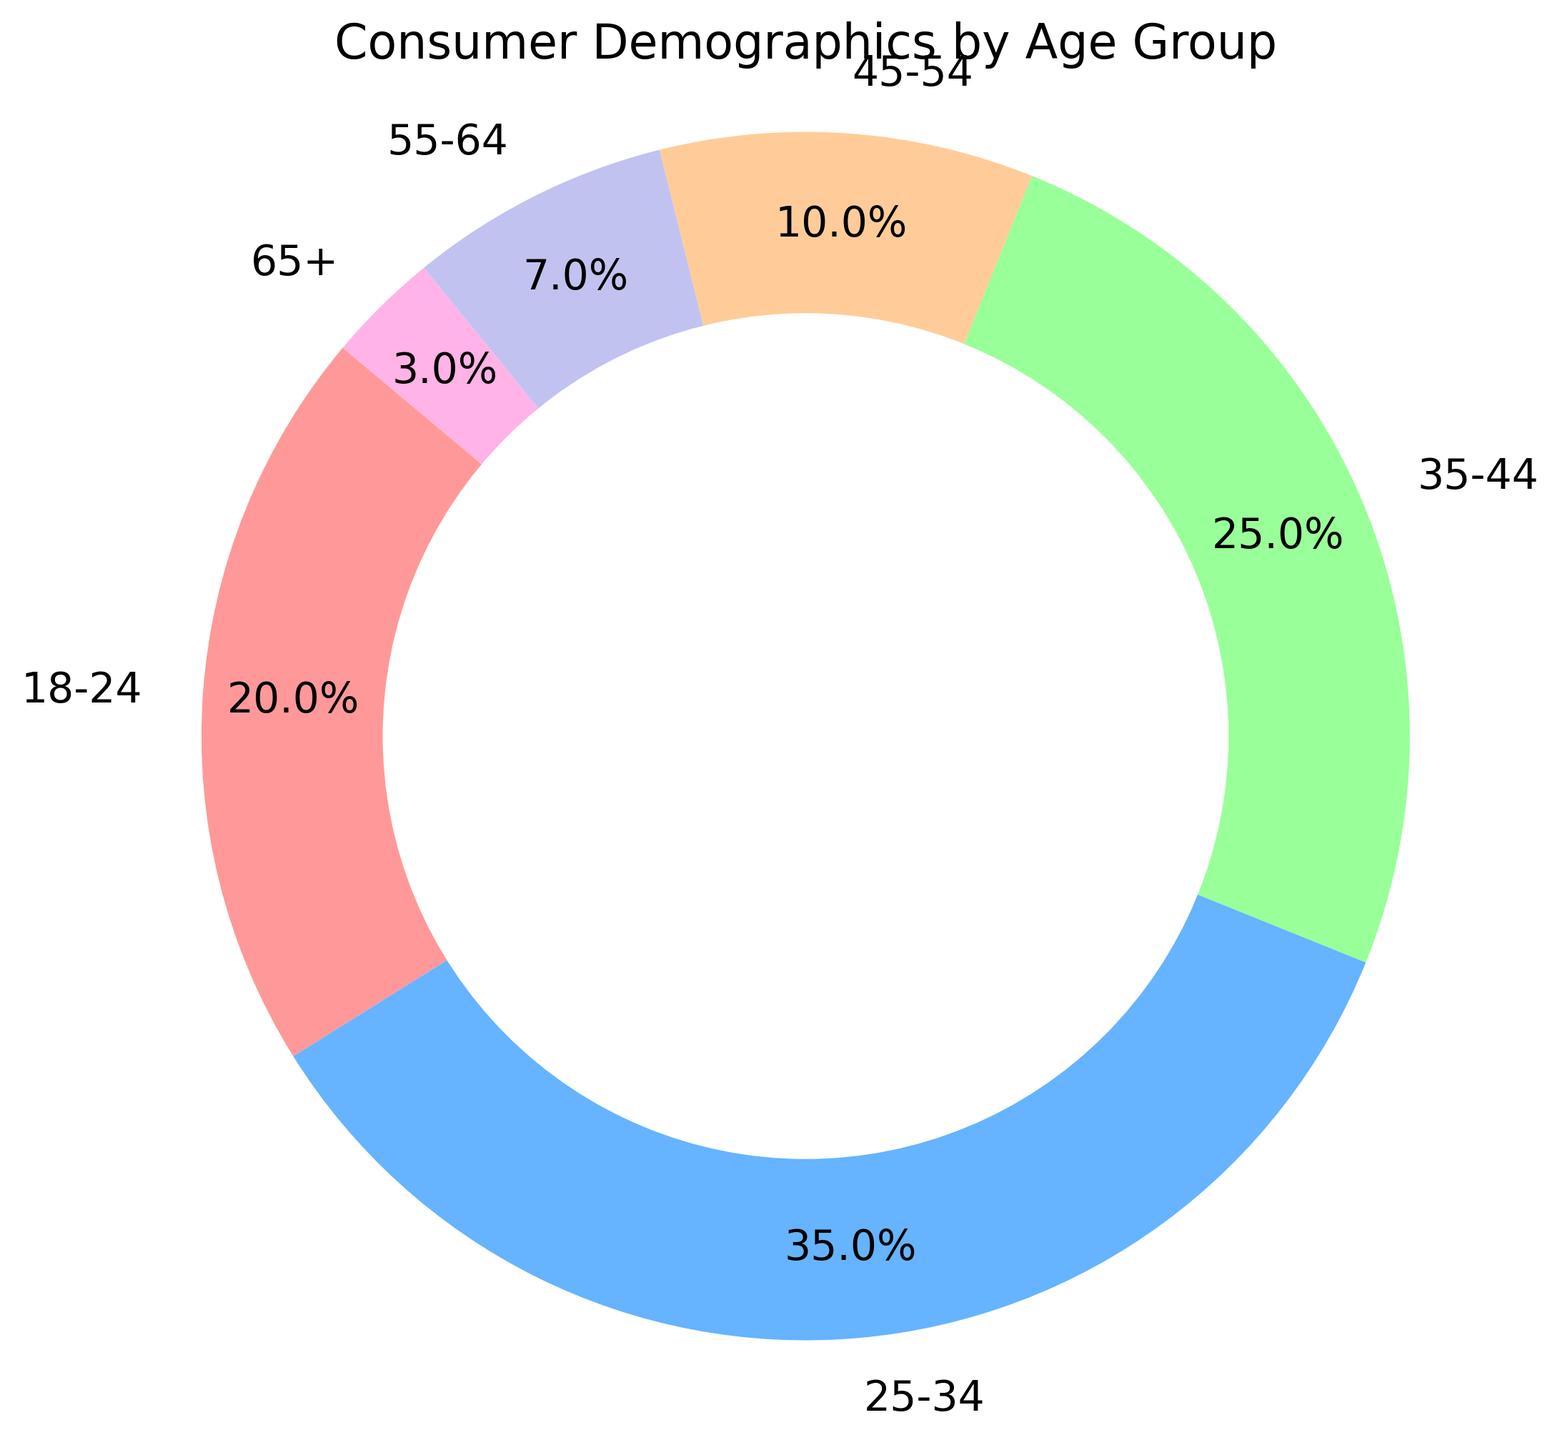What age group has the highest percentage of consumers for the specific product? Observing the pie chart, the largest segment represents the 25-34 age group. This segment occupies 35% of the chart, which is larger than any other group.
Answer: 25-34 Which two age groups together make up 70% of consumers? Adding the percentages of the two largest segments: 25-34 makes up 35% and 35-44 makes up 25%. Together, 35% + 25% equals 60%. To reach 70%, we need another 10%, which comes from the 18-24 group. Thus, 25-34 (35%) + 35-44 (25%) + 18-24 (20%) equals 70%.
Answer: 25-34 and 35-44 What is the difference in consumer percentage between the 18-24 age group and the 65+ age group? The 18-24 age group has 20%, while the 65+ age group has 3%. 20% - 3% equals a 17% difference.
Answer: 17% How does the consumer percentage of the 55-64 age group compare to the 45-54 age group? The chart shows that the 45-54 age group comprises 10%, whereas the 55-64 age group makes up 7%. Therefore, the 55-64 age group is 3% less than the 45-54 age group.
Answer: 3% less What is the total percentage of consumers aged 35 and above? Summing up the percentages of age groups 35-44 (25%), 45-54 (10%), 55-64 (7%), and 65+ (3%) gives 25% + 10% + 7% + 3% = 45%.
Answer: 45% Which color represents the 18-24 age group, and what is its percentage? The pie chart shows the 18-24 age group in red, and it occupies 20% of the chart.
Answer: Red, 20% Among the age groups, which one has the least percentage of consumers, and what color is used to represent it? The 65+ age group has the smallest segment at 3%, and it is represented by a pinkish color.
Answer: 65+, pink How much larger is the percentage of the 25-34 age group compared to the 55-64 age group? The 25-34 age group constitutes 35%, while the 55-64 age group constitutes 7%. The difference is 35% - 7%, which equals 28%.
Answer: 28% What is the sum of the percentages of the two smallest age groups? The two smallest age groups are 65+ (3%) and 55-64 (7%). Adding these gives 3% + 7% = 10%.
Answer: 10% If the 18-24 and 45-54 age groups are combined, what percentage of the total consumer demographic do they represent? The 18-24 age group is 20%, and the 45-54 age group is 10%. Their combined total is 20% + 10%, which equals 30%.
Answer: 30% 